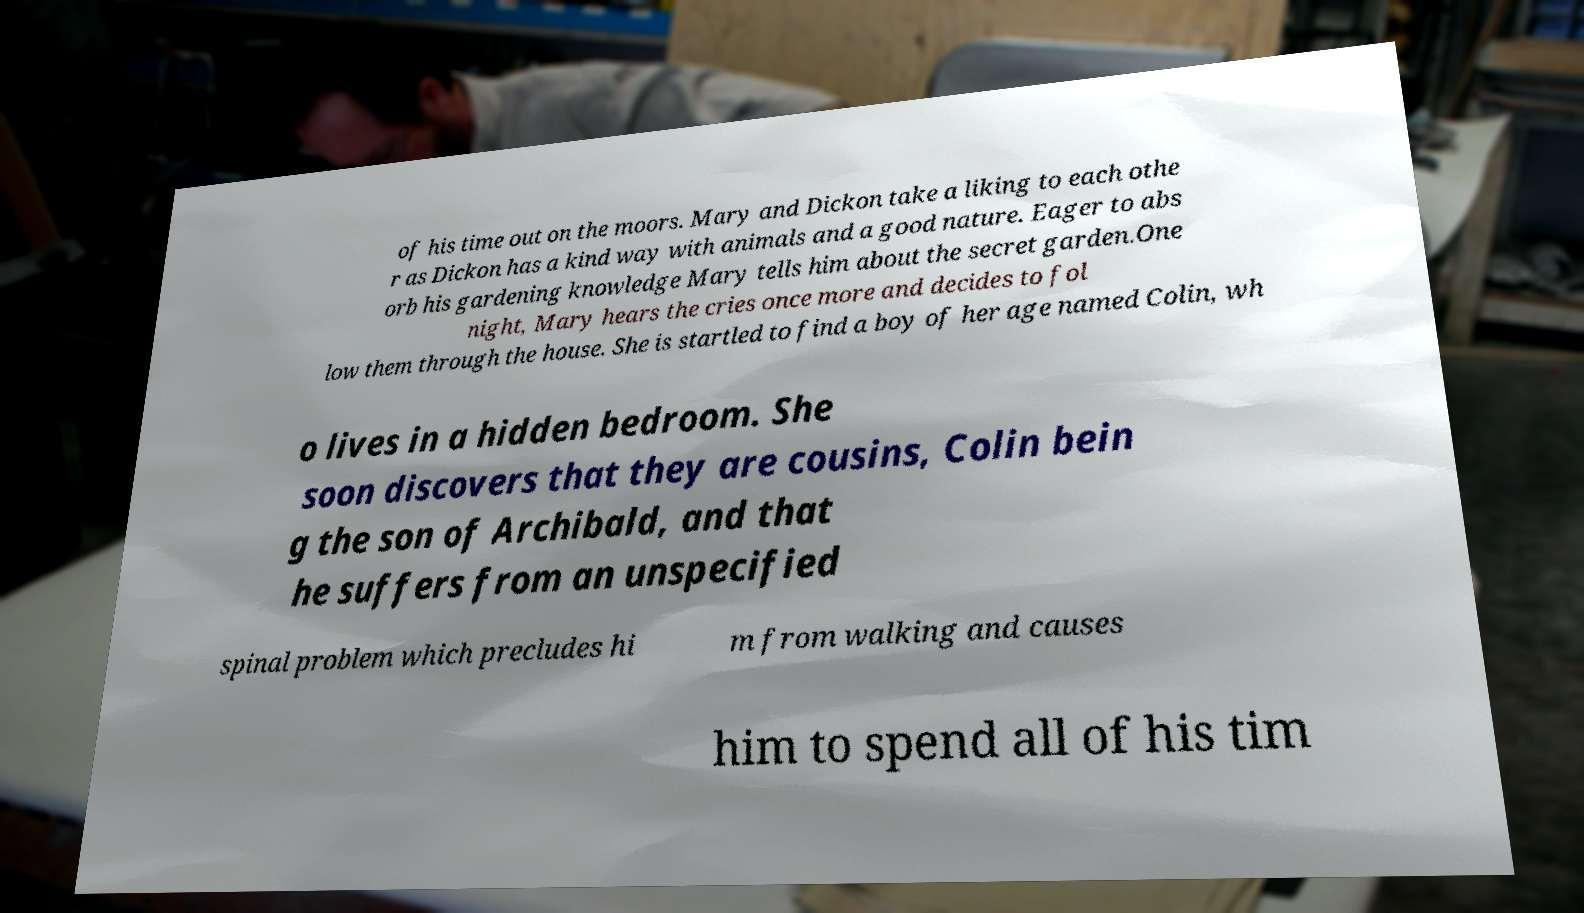Can you accurately transcribe the text from the provided image for me? of his time out on the moors. Mary and Dickon take a liking to each othe r as Dickon has a kind way with animals and a good nature. Eager to abs orb his gardening knowledge Mary tells him about the secret garden.One night, Mary hears the cries once more and decides to fol low them through the house. She is startled to find a boy of her age named Colin, wh o lives in a hidden bedroom. She soon discovers that they are cousins, Colin bein g the son of Archibald, and that he suffers from an unspecified spinal problem which precludes hi m from walking and causes him to spend all of his tim 